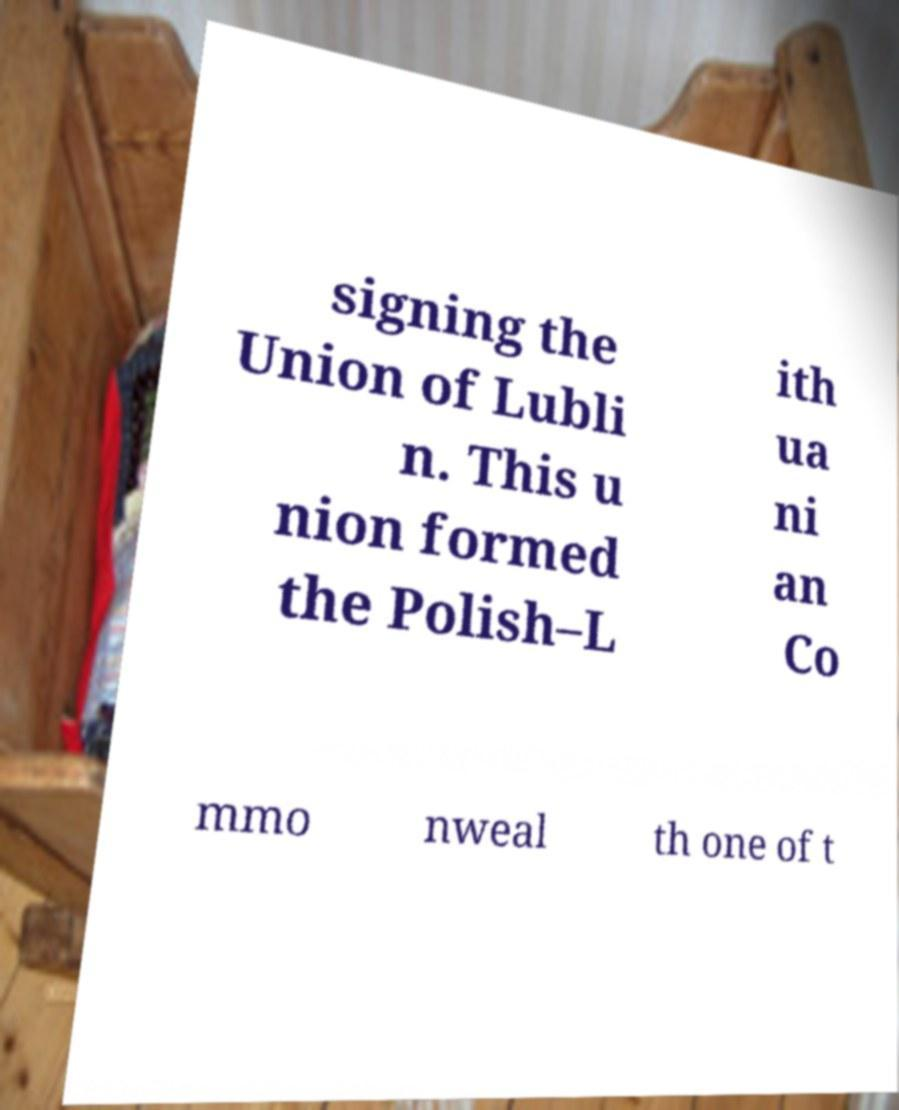Please read and relay the text visible in this image. What does it say? signing the Union of Lubli n. This u nion formed the Polish–L ith ua ni an Co mmo nweal th one of t 